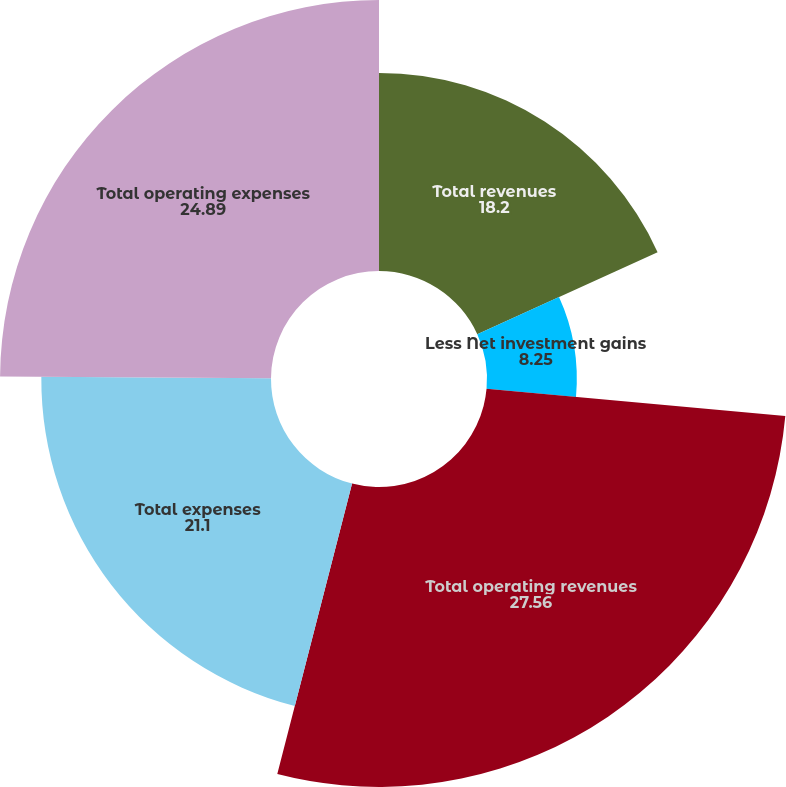Convert chart. <chart><loc_0><loc_0><loc_500><loc_500><pie_chart><fcel>Total revenues<fcel>Less Net investment gains<fcel>Total operating revenues<fcel>Total expenses<fcel>Total operating expenses<nl><fcel>18.2%<fcel>8.25%<fcel>27.56%<fcel>21.1%<fcel>24.89%<nl></chart> 